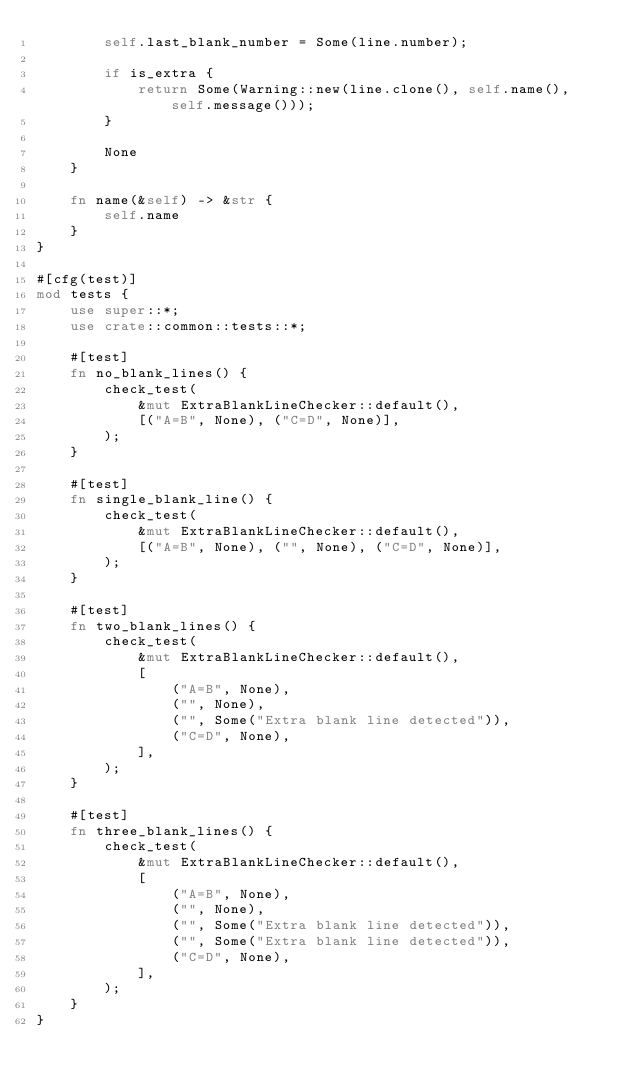Convert code to text. <code><loc_0><loc_0><loc_500><loc_500><_Rust_>        self.last_blank_number = Some(line.number);

        if is_extra {
            return Some(Warning::new(line.clone(), self.name(), self.message()));
        }

        None
    }

    fn name(&self) -> &str {
        self.name
    }
}

#[cfg(test)]
mod tests {
    use super::*;
    use crate::common::tests::*;

    #[test]
    fn no_blank_lines() {
        check_test(
            &mut ExtraBlankLineChecker::default(),
            [("A=B", None), ("C=D", None)],
        );
    }

    #[test]
    fn single_blank_line() {
        check_test(
            &mut ExtraBlankLineChecker::default(),
            [("A=B", None), ("", None), ("C=D", None)],
        );
    }

    #[test]
    fn two_blank_lines() {
        check_test(
            &mut ExtraBlankLineChecker::default(),
            [
                ("A=B", None),
                ("", None),
                ("", Some("Extra blank line detected")),
                ("C=D", None),
            ],
        );
    }

    #[test]
    fn three_blank_lines() {
        check_test(
            &mut ExtraBlankLineChecker::default(),
            [
                ("A=B", None),
                ("", None),
                ("", Some("Extra blank line detected")),
                ("", Some("Extra blank line detected")),
                ("C=D", None),
            ],
        );
    }
}
</code> 